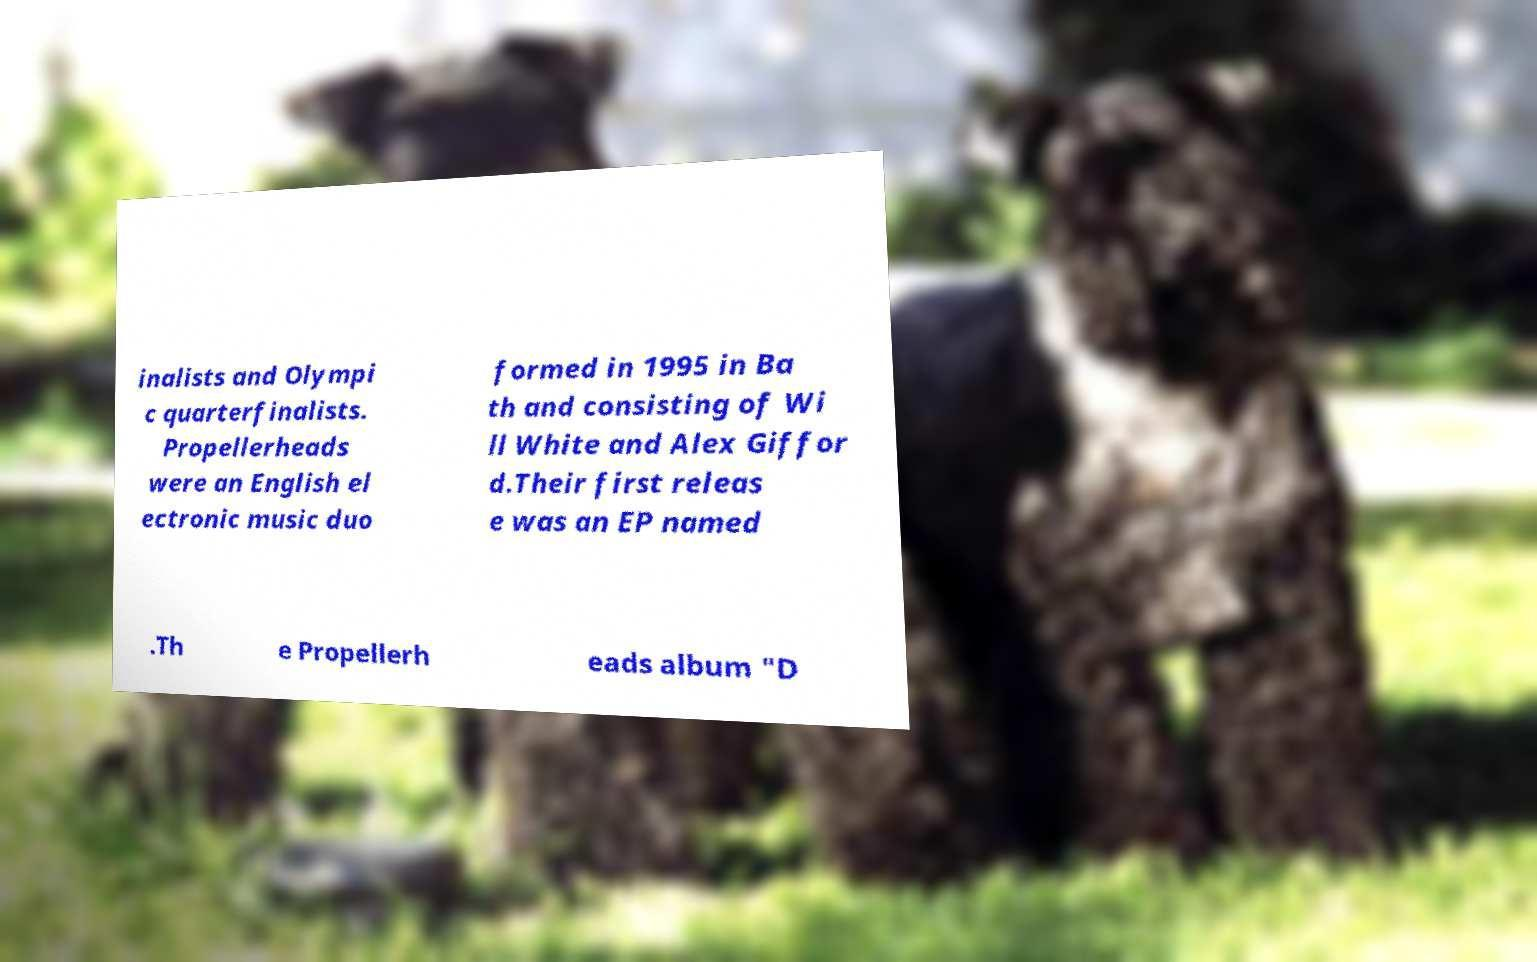What messages or text are displayed in this image? I need them in a readable, typed format. inalists and Olympi c quarterfinalists. Propellerheads were an English el ectronic music duo formed in 1995 in Ba th and consisting of Wi ll White and Alex Giffor d.Their first releas e was an EP named .Th e Propellerh eads album "D 